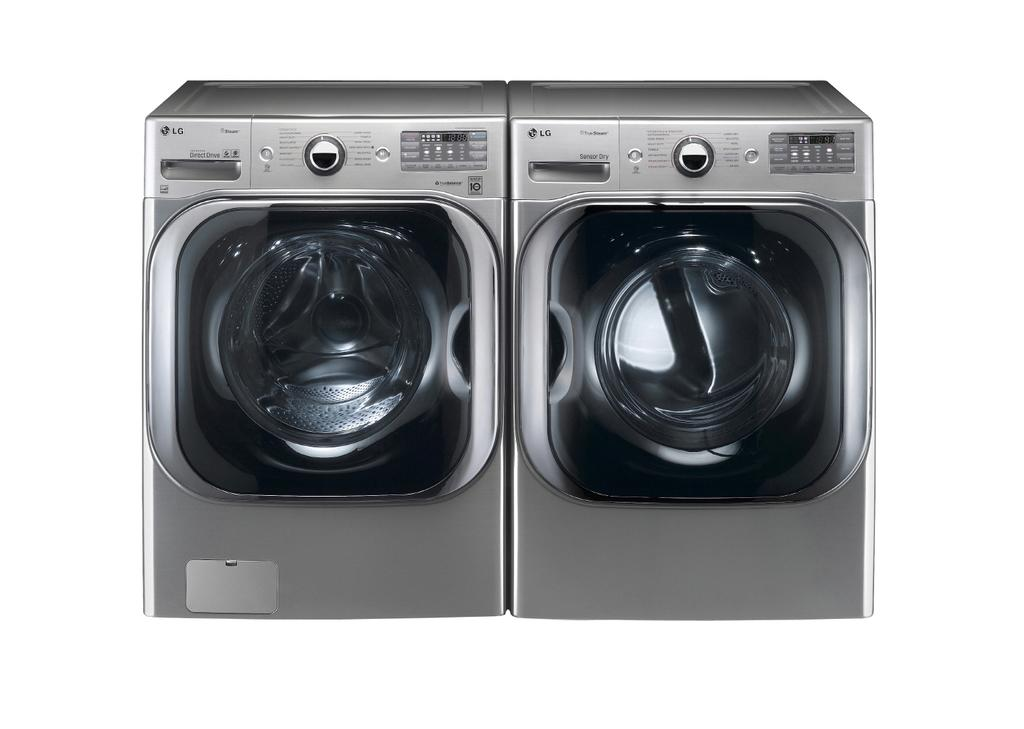What appliances are present in the image? There are two washing machines in the image. What color is the background of the image? The background of the image is white. What flavor of toothpaste is being used in the image? There is no toothpaste present in the image; it features two washing machines and a white background. What type of nose can be seen on the washing machines in the image? Washing machines do not have noses, so there is no nose to be seen in the image. 